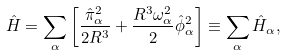<formula> <loc_0><loc_0><loc_500><loc_500>\hat { H } = \sum _ { \alpha } \left [ \frac { \hat { \pi } ^ { 2 } _ { \alpha } } { 2 R ^ { 3 } } + \frac { R ^ { 3 } \omega _ { \alpha } ^ { 2 } } { 2 } \hat { \phi } _ { \alpha } ^ { 2 } \right ] \equiv \sum _ { \alpha } \hat { H } _ { \alpha } ,</formula> 